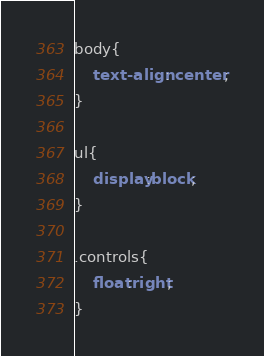<code> <loc_0><loc_0><loc_500><loc_500><_CSS_>body{
	text-align: center;
}

ul{
	display:block;
}

.controls{
	float:right;
}</code> 